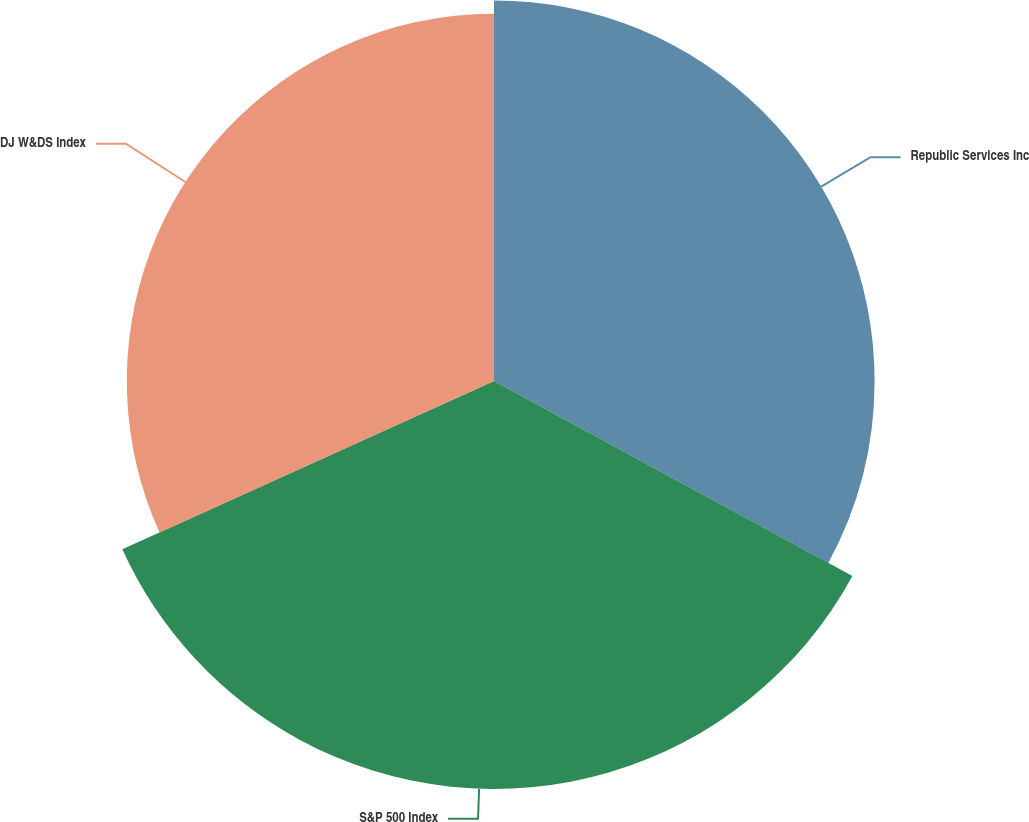Convert chart. <chart><loc_0><loc_0><loc_500><loc_500><pie_chart><fcel>Republic Services Inc<fcel>S&P 500 Index<fcel>DJ W&DS Index<nl><fcel>32.93%<fcel>35.3%<fcel>31.77%<nl></chart> 